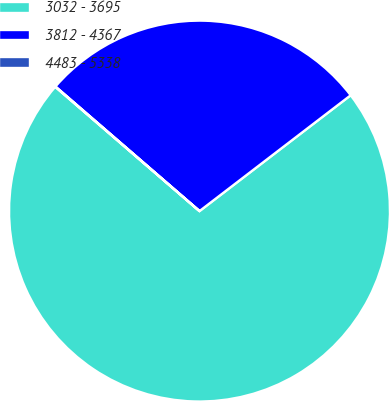Convert chart to OTSL. <chart><loc_0><loc_0><loc_500><loc_500><pie_chart><fcel>3032 - 3695<fcel>3812 - 4367<fcel>4483 - 5338<nl><fcel>71.72%<fcel>28.25%<fcel>0.03%<nl></chart> 